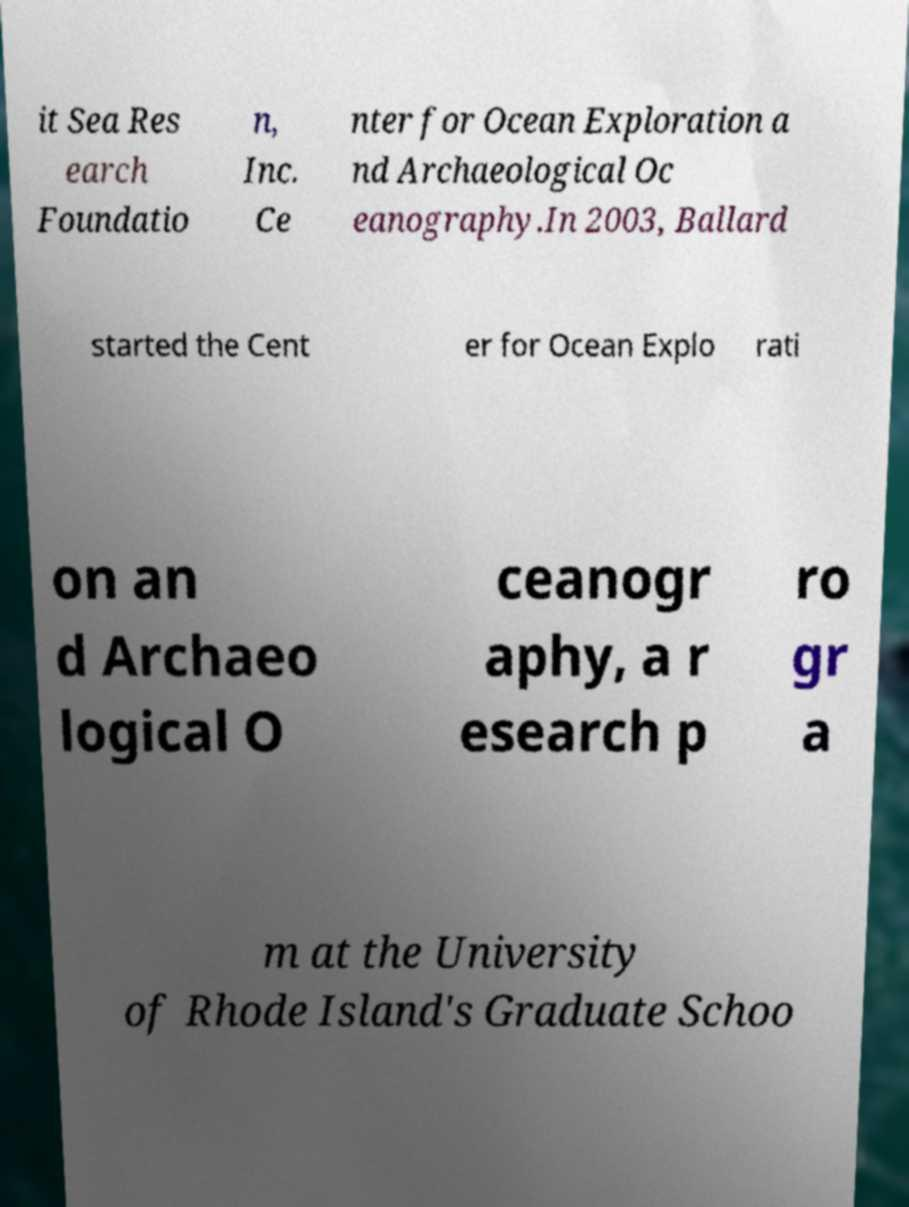Can you accurately transcribe the text from the provided image for me? it Sea Res earch Foundatio n, Inc. Ce nter for Ocean Exploration a nd Archaeological Oc eanography.In 2003, Ballard started the Cent er for Ocean Explo rati on an d Archaeo logical O ceanogr aphy, a r esearch p ro gr a m at the University of Rhode Island's Graduate Schoo 